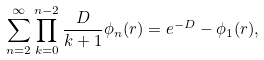Convert formula to latex. <formula><loc_0><loc_0><loc_500><loc_500>\sum _ { n = 2 } ^ { \infty } \prod _ { k = 0 } ^ { n - 2 } \frac { D } { k + 1 } \phi _ { n } ( r ) = e ^ { - D } - \phi _ { 1 } ( r ) ,</formula> 